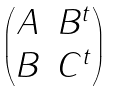Convert formula to latex. <formula><loc_0><loc_0><loc_500><loc_500>\begin{pmatrix} A & B ^ { t } \\ B & C ^ { t } \end{pmatrix}</formula> 